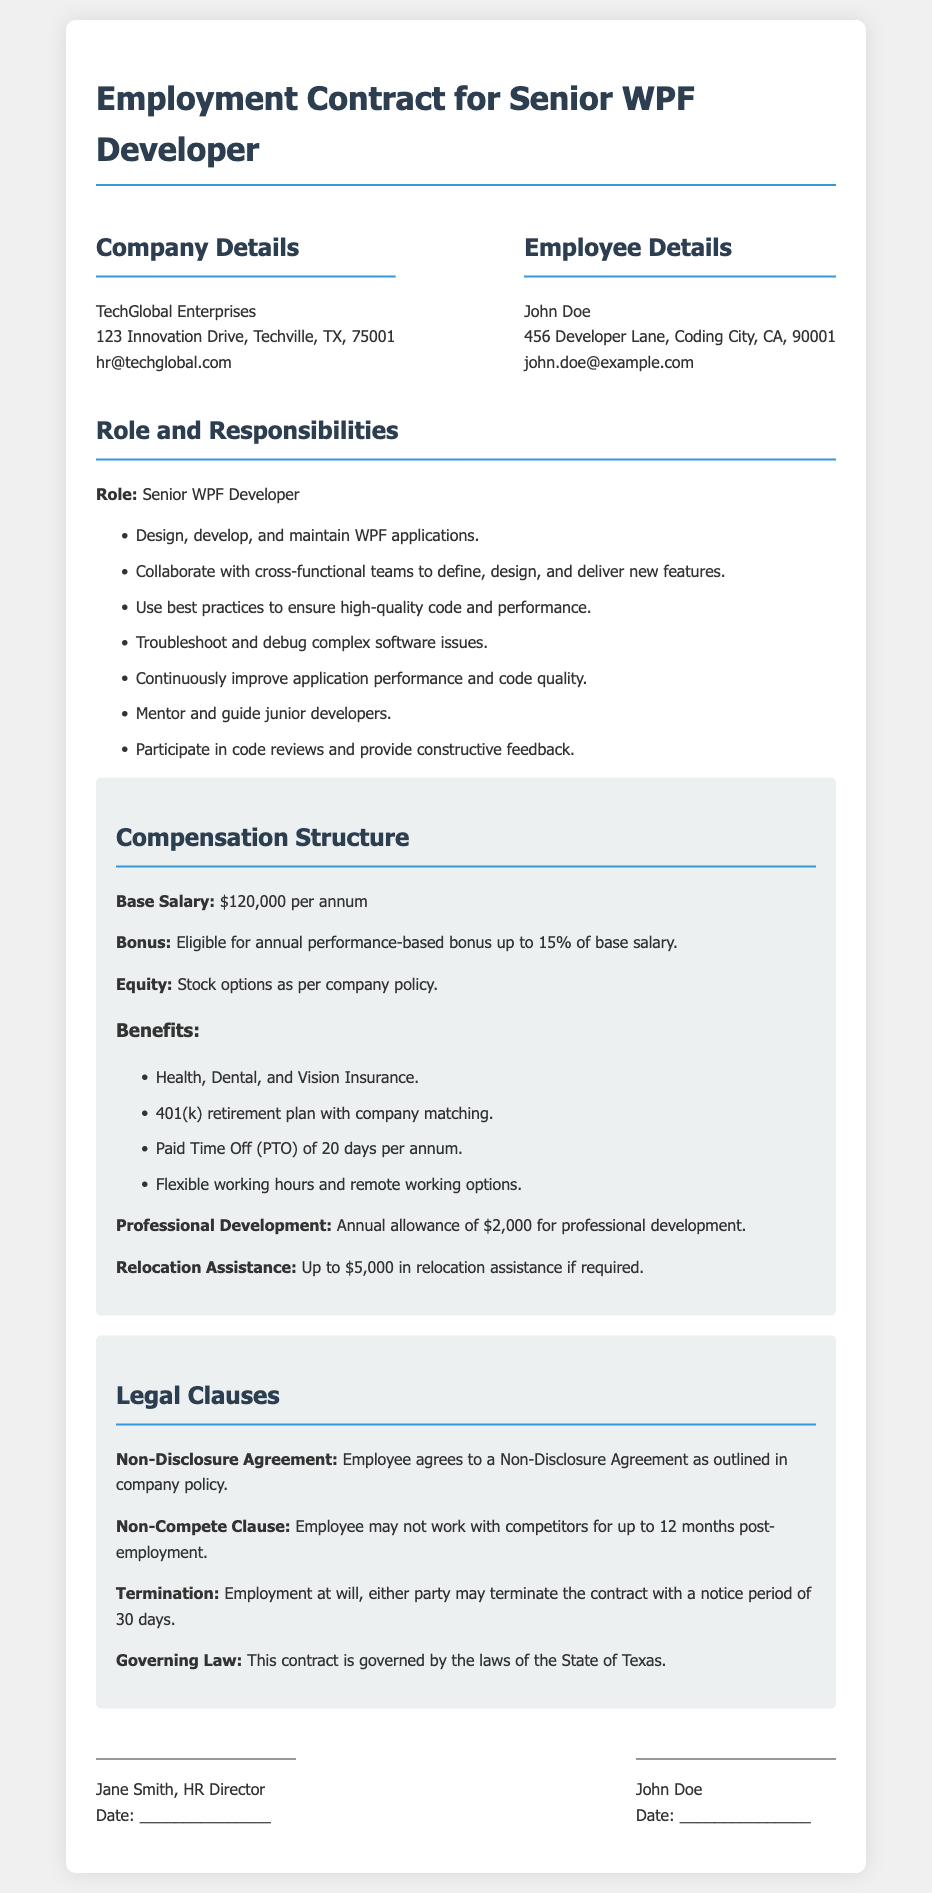What is the employee's name? The employee's name is listed in the document as John Doe.
Answer: John Doe What is the base salary offered? The document specifies the base salary as $120,000 per annum.
Answer: $120,000 per annum What responsibilities include mentoring? The responsibilities include mentoring and guiding junior developers.
Answer: Mentoring and guiding junior developers What is the maximum annual bonus percentage? The maximum annual performance-based bonus is stated as up to 15% of the base salary.
Answer: 15% What is the notice period for termination? The notice period for termination of the contract is indicated as 30 days.
Answer: 30 days Which insurance plans are included in benefits? The benefits section lists health, dental, and vision insurance.
Answer: Health, Dental, and Vision Insurance What is the governing law for this contract? The governing law for the contract is defined as the laws of the State of Texas.
Answer: State of Texas How much is the annual allowance for professional development? The contract specifies an annual allowance of $2,000 for professional development.
Answer: $2,000 What type of clause prohibits working with competitors? The document includes a non-compete clause that prohibits working with competitors.
Answer: Non-compete clause 